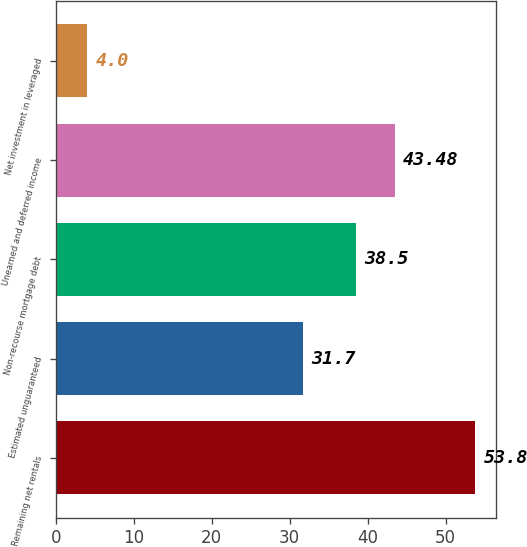Convert chart. <chart><loc_0><loc_0><loc_500><loc_500><bar_chart><fcel>Remaining net rentals<fcel>Estimated unguaranteed<fcel>Non-recourse mortgage debt<fcel>Unearned and deferred income<fcel>Net investment in leveraged<nl><fcel>53.8<fcel>31.7<fcel>38.5<fcel>43.48<fcel>4<nl></chart> 